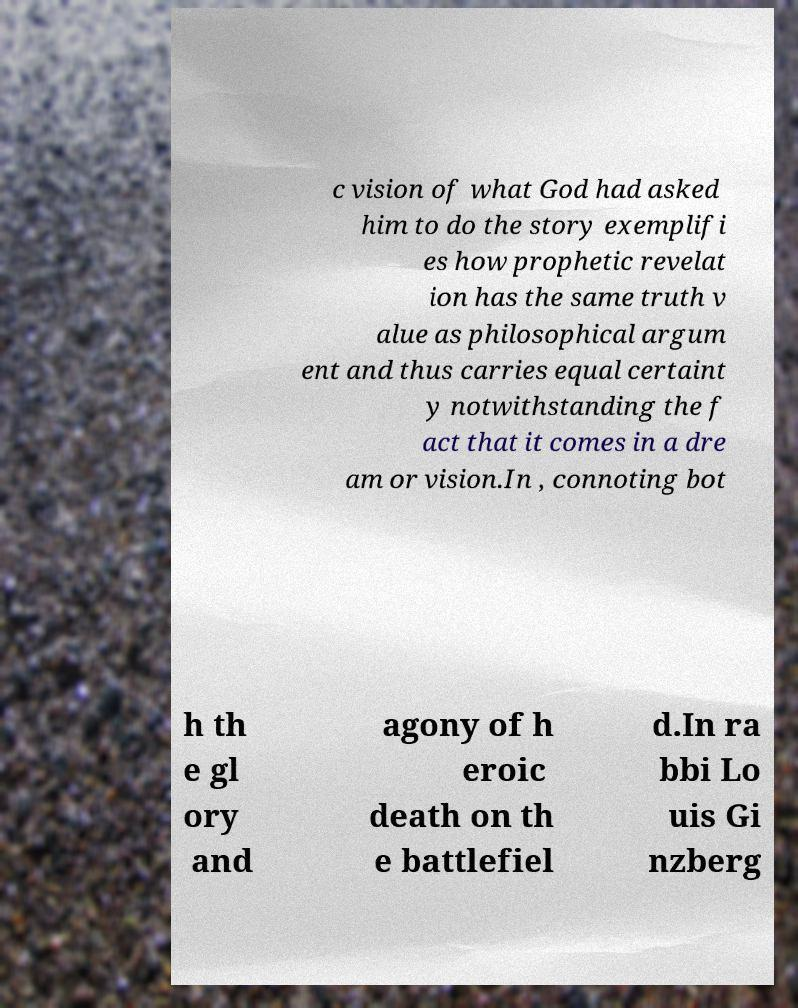What messages or text are displayed in this image? I need them in a readable, typed format. c vision of what God had asked him to do the story exemplifi es how prophetic revelat ion has the same truth v alue as philosophical argum ent and thus carries equal certaint y notwithstanding the f act that it comes in a dre am or vision.In , connoting bot h th e gl ory and agony of h eroic death on th e battlefiel d.In ra bbi Lo uis Gi nzberg 